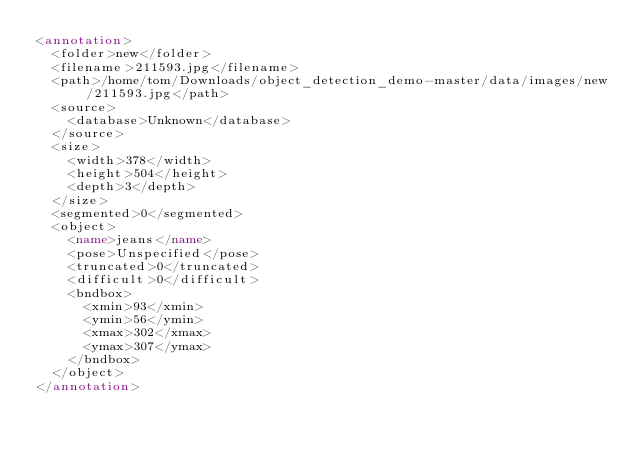<code> <loc_0><loc_0><loc_500><loc_500><_XML_><annotation>
	<folder>new</folder>
	<filename>211593.jpg</filename>
	<path>/home/tom/Downloads/object_detection_demo-master/data/images/new/211593.jpg</path>
	<source>
		<database>Unknown</database>
	</source>
	<size>
		<width>378</width>
		<height>504</height>
		<depth>3</depth>
	</size>
	<segmented>0</segmented>
	<object>
		<name>jeans</name>
		<pose>Unspecified</pose>
		<truncated>0</truncated>
		<difficult>0</difficult>
		<bndbox>
			<xmin>93</xmin>
			<ymin>56</ymin>
			<xmax>302</xmax>
			<ymax>307</ymax>
		</bndbox>
	</object>
</annotation>
</code> 